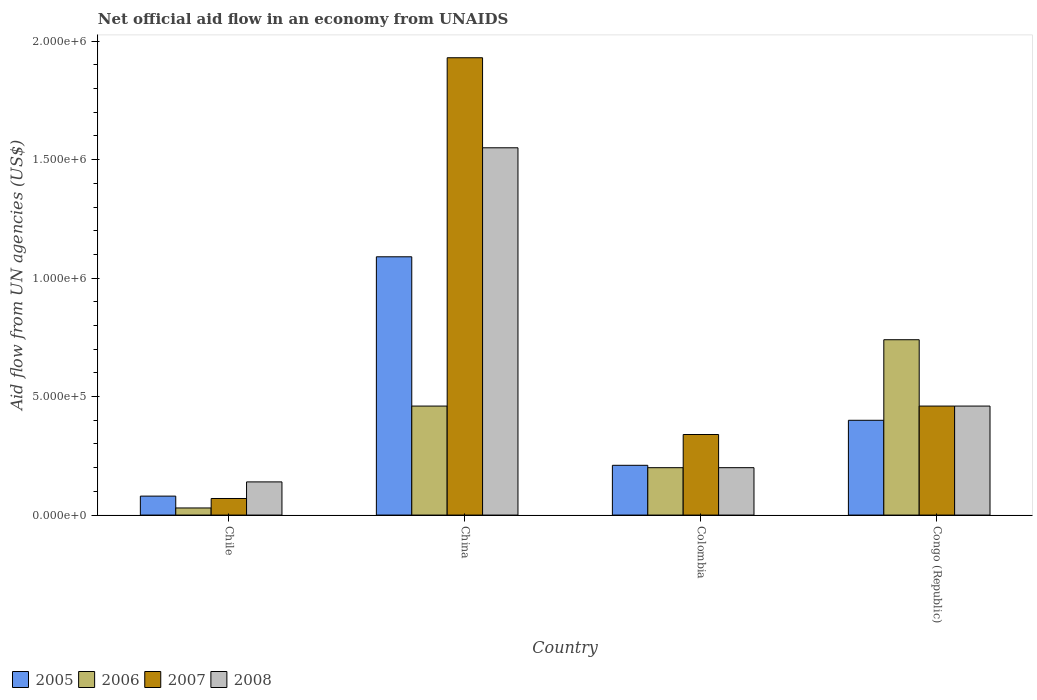How many different coloured bars are there?
Keep it short and to the point. 4. How many groups of bars are there?
Your answer should be compact. 4. Are the number of bars per tick equal to the number of legend labels?
Offer a terse response. Yes. How many bars are there on the 3rd tick from the right?
Ensure brevity in your answer.  4. What is the label of the 1st group of bars from the left?
Offer a terse response. Chile. Across all countries, what is the maximum net official aid flow in 2005?
Make the answer very short. 1.09e+06. Across all countries, what is the minimum net official aid flow in 2006?
Offer a very short reply. 3.00e+04. What is the total net official aid flow in 2008 in the graph?
Provide a short and direct response. 2.35e+06. What is the difference between the net official aid flow in 2006 in Colombia and that in Congo (Republic)?
Your response must be concise. -5.40e+05. What is the difference between the net official aid flow in 2005 in Chile and the net official aid flow in 2006 in China?
Provide a succinct answer. -3.80e+05. What is the difference between the net official aid flow of/in 2006 and net official aid flow of/in 2008 in China?
Ensure brevity in your answer.  -1.09e+06. In how many countries, is the net official aid flow in 2008 greater than 400000 US$?
Give a very brief answer. 2. Is the net official aid flow in 2007 in Chile less than that in Congo (Republic)?
Your answer should be compact. Yes. What is the difference between the highest and the second highest net official aid flow in 2006?
Your response must be concise. 2.80e+05. What is the difference between the highest and the lowest net official aid flow in 2008?
Ensure brevity in your answer.  1.41e+06. What does the 4th bar from the right in Colombia represents?
Your answer should be compact. 2005. Is it the case that in every country, the sum of the net official aid flow in 2006 and net official aid flow in 2005 is greater than the net official aid flow in 2008?
Provide a short and direct response. No. How many bars are there?
Give a very brief answer. 16. How many countries are there in the graph?
Ensure brevity in your answer.  4. Are the values on the major ticks of Y-axis written in scientific E-notation?
Make the answer very short. Yes. Does the graph contain grids?
Give a very brief answer. No. Where does the legend appear in the graph?
Your response must be concise. Bottom left. How are the legend labels stacked?
Keep it short and to the point. Horizontal. What is the title of the graph?
Offer a terse response. Net official aid flow in an economy from UNAIDS. What is the label or title of the X-axis?
Your answer should be compact. Country. What is the label or title of the Y-axis?
Keep it short and to the point. Aid flow from UN agencies (US$). What is the Aid flow from UN agencies (US$) in 2005 in China?
Provide a succinct answer. 1.09e+06. What is the Aid flow from UN agencies (US$) of 2006 in China?
Make the answer very short. 4.60e+05. What is the Aid flow from UN agencies (US$) in 2007 in China?
Your answer should be compact. 1.93e+06. What is the Aid flow from UN agencies (US$) of 2008 in China?
Make the answer very short. 1.55e+06. What is the Aid flow from UN agencies (US$) of 2005 in Colombia?
Offer a very short reply. 2.10e+05. What is the Aid flow from UN agencies (US$) in 2006 in Colombia?
Make the answer very short. 2.00e+05. What is the Aid flow from UN agencies (US$) of 2007 in Colombia?
Give a very brief answer. 3.40e+05. What is the Aid flow from UN agencies (US$) in 2005 in Congo (Republic)?
Your response must be concise. 4.00e+05. What is the Aid flow from UN agencies (US$) of 2006 in Congo (Republic)?
Provide a short and direct response. 7.40e+05. What is the Aid flow from UN agencies (US$) in 2007 in Congo (Republic)?
Offer a very short reply. 4.60e+05. Across all countries, what is the maximum Aid flow from UN agencies (US$) of 2005?
Your answer should be compact. 1.09e+06. Across all countries, what is the maximum Aid flow from UN agencies (US$) in 2006?
Your answer should be very brief. 7.40e+05. Across all countries, what is the maximum Aid flow from UN agencies (US$) of 2007?
Keep it short and to the point. 1.93e+06. Across all countries, what is the maximum Aid flow from UN agencies (US$) in 2008?
Ensure brevity in your answer.  1.55e+06. Across all countries, what is the minimum Aid flow from UN agencies (US$) in 2008?
Make the answer very short. 1.40e+05. What is the total Aid flow from UN agencies (US$) in 2005 in the graph?
Offer a very short reply. 1.78e+06. What is the total Aid flow from UN agencies (US$) in 2006 in the graph?
Provide a succinct answer. 1.43e+06. What is the total Aid flow from UN agencies (US$) in 2007 in the graph?
Provide a succinct answer. 2.80e+06. What is the total Aid flow from UN agencies (US$) of 2008 in the graph?
Provide a succinct answer. 2.35e+06. What is the difference between the Aid flow from UN agencies (US$) of 2005 in Chile and that in China?
Offer a very short reply. -1.01e+06. What is the difference between the Aid flow from UN agencies (US$) in 2006 in Chile and that in China?
Offer a very short reply. -4.30e+05. What is the difference between the Aid flow from UN agencies (US$) in 2007 in Chile and that in China?
Keep it short and to the point. -1.86e+06. What is the difference between the Aid flow from UN agencies (US$) of 2008 in Chile and that in China?
Provide a succinct answer. -1.41e+06. What is the difference between the Aid flow from UN agencies (US$) in 2006 in Chile and that in Colombia?
Keep it short and to the point. -1.70e+05. What is the difference between the Aid flow from UN agencies (US$) in 2007 in Chile and that in Colombia?
Give a very brief answer. -2.70e+05. What is the difference between the Aid flow from UN agencies (US$) in 2008 in Chile and that in Colombia?
Your answer should be very brief. -6.00e+04. What is the difference between the Aid flow from UN agencies (US$) of 2005 in Chile and that in Congo (Republic)?
Your response must be concise. -3.20e+05. What is the difference between the Aid flow from UN agencies (US$) in 2006 in Chile and that in Congo (Republic)?
Offer a terse response. -7.10e+05. What is the difference between the Aid flow from UN agencies (US$) of 2007 in Chile and that in Congo (Republic)?
Provide a succinct answer. -3.90e+05. What is the difference between the Aid flow from UN agencies (US$) in 2008 in Chile and that in Congo (Republic)?
Ensure brevity in your answer.  -3.20e+05. What is the difference between the Aid flow from UN agencies (US$) in 2005 in China and that in Colombia?
Your answer should be compact. 8.80e+05. What is the difference between the Aid flow from UN agencies (US$) in 2007 in China and that in Colombia?
Your answer should be very brief. 1.59e+06. What is the difference between the Aid flow from UN agencies (US$) of 2008 in China and that in Colombia?
Give a very brief answer. 1.35e+06. What is the difference between the Aid flow from UN agencies (US$) of 2005 in China and that in Congo (Republic)?
Your response must be concise. 6.90e+05. What is the difference between the Aid flow from UN agencies (US$) in 2006 in China and that in Congo (Republic)?
Offer a terse response. -2.80e+05. What is the difference between the Aid flow from UN agencies (US$) of 2007 in China and that in Congo (Republic)?
Make the answer very short. 1.47e+06. What is the difference between the Aid flow from UN agencies (US$) in 2008 in China and that in Congo (Republic)?
Make the answer very short. 1.09e+06. What is the difference between the Aid flow from UN agencies (US$) of 2006 in Colombia and that in Congo (Republic)?
Your response must be concise. -5.40e+05. What is the difference between the Aid flow from UN agencies (US$) in 2007 in Colombia and that in Congo (Republic)?
Your response must be concise. -1.20e+05. What is the difference between the Aid flow from UN agencies (US$) in 2005 in Chile and the Aid flow from UN agencies (US$) in 2006 in China?
Your answer should be very brief. -3.80e+05. What is the difference between the Aid flow from UN agencies (US$) of 2005 in Chile and the Aid flow from UN agencies (US$) of 2007 in China?
Provide a short and direct response. -1.85e+06. What is the difference between the Aid flow from UN agencies (US$) in 2005 in Chile and the Aid flow from UN agencies (US$) in 2008 in China?
Provide a short and direct response. -1.47e+06. What is the difference between the Aid flow from UN agencies (US$) of 2006 in Chile and the Aid flow from UN agencies (US$) of 2007 in China?
Your answer should be very brief. -1.90e+06. What is the difference between the Aid flow from UN agencies (US$) in 2006 in Chile and the Aid flow from UN agencies (US$) in 2008 in China?
Your response must be concise. -1.52e+06. What is the difference between the Aid flow from UN agencies (US$) in 2007 in Chile and the Aid flow from UN agencies (US$) in 2008 in China?
Your answer should be very brief. -1.48e+06. What is the difference between the Aid flow from UN agencies (US$) of 2005 in Chile and the Aid flow from UN agencies (US$) of 2006 in Colombia?
Provide a short and direct response. -1.20e+05. What is the difference between the Aid flow from UN agencies (US$) of 2005 in Chile and the Aid flow from UN agencies (US$) of 2007 in Colombia?
Provide a short and direct response. -2.60e+05. What is the difference between the Aid flow from UN agencies (US$) of 2006 in Chile and the Aid flow from UN agencies (US$) of 2007 in Colombia?
Keep it short and to the point. -3.10e+05. What is the difference between the Aid flow from UN agencies (US$) of 2007 in Chile and the Aid flow from UN agencies (US$) of 2008 in Colombia?
Your answer should be compact. -1.30e+05. What is the difference between the Aid flow from UN agencies (US$) of 2005 in Chile and the Aid flow from UN agencies (US$) of 2006 in Congo (Republic)?
Ensure brevity in your answer.  -6.60e+05. What is the difference between the Aid flow from UN agencies (US$) of 2005 in Chile and the Aid flow from UN agencies (US$) of 2007 in Congo (Republic)?
Give a very brief answer. -3.80e+05. What is the difference between the Aid flow from UN agencies (US$) in 2005 in Chile and the Aid flow from UN agencies (US$) in 2008 in Congo (Republic)?
Your response must be concise. -3.80e+05. What is the difference between the Aid flow from UN agencies (US$) in 2006 in Chile and the Aid flow from UN agencies (US$) in 2007 in Congo (Republic)?
Ensure brevity in your answer.  -4.30e+05. What is the difference between the Aid flow from UN agencies (US$) of 2006 in Chile and the Aid flow from UN agencies (US$) of 2008 in Congo (Republic)?
Make the answer very short. -4.30e+05. What is the difference between the Aid flow from UN agencies (US$) in 2007 in Chile and the Aid flow from UN agencies (US$) in 2008 in Congo (Republic)?
Provide a short and direct response. -3.90e+05. What is the difference between the Aid flow from UN agencies (US$) of 2005 in China and the Aid flow from UN agencies (US$) of 2006 in Colombia?
Offer a terse response. 8.90e+05. What is the difference between the Aid flow from UN agencies (US$) in 2005 in China and the Aid flow from UN agencies (US$) in 2007 in Colombia?
Your answer should be very brief. 7.50e+05. What is the difference between the Aid flow from UN agencies (US$) in 2005 in China and the Aid flow from UN agencies (US$) in 2008 in Colombia?
Ensure brevity in your answer.  8.90e+05. What is the difference between the Aid flow from UN agencies (US$) of 2007 in China and the Aid flow from UN agencies (US$) of 2008 in Colombia?
Make the answer very short. 1.73e+06. What is the difference between the Aid flow from UN agencies (US$) in 2005 in China and the Aid flow from UN agencies (US$) in 2007 in Congo (Republic)?
Offer a terse response. 6.30e+05. What is the difference between the Aid flow from UN agencies (US$) in 2005 in China and the Aid flow from UN agencies (US$) in 2008 in Congo (Republic)?
Make the answer very short. 6.30e+05. What is the difference between the Aid flow from UN agencies (US$) of 2006 in China and the Aid flow from UN agencies (US$) of 2008 in Congo (Republic)?
Ensure brevity in your answer.  0. What is the difference between the Aid flow from UN agencies (US$) of 2007 in China and the Aid flow from UN agencies (US$) of 2008 in Congo (Republic)?
Make the answer very short. 1.47e+06. What is the difference between the Aid flow from UN agencies (US$) in 2005 in Colombia and the Aid flow from UN agencies (US$) in 2006 in Congo (Republic)?
Keep it short and to the point. -5.30e+05. What is the difference between the Aid flow from UN agencies (US$) of 2005 in Colombia and the Aid flow from UN agencies (US$) of 2007 in Congo (Republic)?
Provide a short and direct response. -2.50e+05. What is the difference between the Aid flow from UN agencies (US$) in 2005 in Colombia and the Aid flow from UN agencies (US$) in 2008 in Congo (Republic)?
Provide a short and direct response. -2.50e+05. What is the difference between the Aid flow from UN agencies (US$) of 2006 in Colombia and the Aid flow from UN agencies (US$) of 2007 in Congo (Republic)?
Keep it short and to the point. -2.60e+05. What is the difference between the Aid flow from UN agencies (US$) of 2006 in Colombia and the Aid flow from UN agencies (US$) of 2008 in Congo (Republic)?
Ensure brevity in your answer.  -2.60e+05. What is the average Aid flow from UN agencies (US$) in 2005 per country?
Your answer should be compact. 4.45e+05. What is the average Aid flow from UN agencies (US$) in 2006 per country?
Your answer should be very brief. 3.58e+05. What is the average Aid flow from UN agencies (US$) in 2008 per country?
Provide a succinct answer. 5.88e+05. What is the difference between the Aid flow from UN agencies (US$) in 2005 and Aid flow from UN agencies (US$) in 2006 in Chile?
Your answer should be very brief. 5.00e+04. What is the difference between the Aid flow from UN agencies (US$) in 2005 and Aid flow from UN agencies (US$) in 2007 in Chile?
Make the answer very short. 10000. What is the difference between the Aid flow from UN agencies (US$) of 2005 and Aid flow from UN agencies (US$) of 2008 in Chile?
Keep it short and to the point. -6.00e+04. What is the difference between the Aid flow from UN agencies (US$) in 2006 and Aid flow from UN agencies (US$) in 2007 in Chile?
Keep it short and to the point. -4.00e+04. What is the difference between the Aid flow from UN agencies (US$) of 2005 and Aid flow from UN agencies (US$) of 2006 in China?
Your answer should be very brief. 6.30e+05. What is the difference between the Aid flow from UN agencies (US$) in 2005 and Aid flow from UN agencies (US$) in 2007 in China?
Provide a succinct answer. -8.40e+05. What is the difference between the Aid flow from UN agencies (US$) in 2005 and Aid flow from UN agencies (US$) in 2008 in China?
Give a very brief answer. -4.60e+05. What is the difference between the Aid flow from UN agencies (US$) in 2006 and Aid flow from UN agencies (US$) in 2007 in China?
Provide a short and direct response. -1.47e+06. What is the difference between the Aid flow from UN agencies (US$) in 2006 and Aid flow from UN agencies (US$) in 2008 in China?
Keep it short and to the point. -1.09e+06. What is the difference between the Aid flow from UN agencies (US$) of 2005 and Aid flow from UN agencies (US$) of 2007 in Colombia?
Provide a succinct answer. -1.30e+05. What is the difference between the Aid flow from UN agencies (US$) in 2006 and Aid flow from UN agencies (US$) in 2008 in Colombia?
Give a very brief answer. 0. What is the difference between the Aid flow from UN agencies (US$) in 2005 and Aid flow from UN agencies (US$) in 2006 in Congo (Republic)?
Provide a succinct answer. -3.40e+05. What is the difference between the Aid flow from UN agencies (US$) in 2005 and Aid flow from UN agencies (US$) in 2007 in Congo (Republic)?
Your response must be concise. -6.00e+04. What is the difference between the Aid flow from UN agencies (US$) in 2005 and Aid flow from UN agencies (US$) in 2008 in Congo (Republic)?
Your answer should be very brief. -6.00e+04. What is the difference between the Aid flow from UN agencies (US$) in 2006 and Aid flow from UN agencies (US$) in 2007 in Congo (Republic)?
Ensure brevity in your answer.  2.80e+05. What is the difference between the Aid flow from UN agencies (US$) in 2006 and Aid flow from UN agencies (US$) in 2008 in Congo (Republic)?
Keep it short and to the point. 2.80e+05. What is the ratio of the Aid flow from UN agencies (US$) in 2005 in Chile to that in China?
Offer a terse response. 0.07. What is the ratio of the Aid flow from UN agencies (US$) of 2006 in Chile to that in China?
Provide a succinct answer. 0.07. What is the ratio of the Aid flow from UN agencies (US$) in 2007 in Chile to that in China?
Provide a succinct answer. 0.04. What is the ratio of the Aid flow from UN agencies (US$) of 2008 in Chile to that in China?
Provide a succinct answer. 0.09. What is the ratio of the Aid flow from UN agencies (US$) in 2005 in Chile to that in Colombia?
Your response must be concise. 0.38. What is the ratio of the Aid flow from UN agencies (US$) in 2006 in Chile to that in Colombia?
Keep it short and to the point. 0.15. What is the ratio of the Aid flow from UN agencies (US$) of 2007 in Chile to that in Colombia?
Your response must be concise. 0.21. What is the ratio of the Aid flow from UN agencies (US$) of 2005 in Chile to that in Congo (Republic)?
Provide a succinct answer. 0.2. What is the ratio of the Aid flow from UN agencies (US$) of 2006 in Chile to that in Congo (Republic)?
Provide a short and direct response. 0.04. What is the ratio of the Aid flow from UN agencies (US$) in 2007 in Chile to that in Congo (Republic)?
Make the answer very short. 0.15. What is the ratio of the Aid flow from UN agencies (US$) of 2008 in Chile to that in Congo (Republic)?
Keep it short and to the point. 0.3. What is the ratio of the Aid flow from UN agencies (US$) of 2005 in China to that in Colombia?
Offer a very short reply. 5.19. What is the ratio of the Aid flow from UN agencies (US$) in 2007 in China to that in Colombia?
Make the answer very short. 5.68. What is the ratio of the Aid flow from UN agencies (US$) of 2008 in China to that in Colombia?
Ensure brevity in your answer.  7.75. What is the ratio of the Aid flow from UN agencies (US$) in 2005 in China to that in Congo (Republic)?
Ensure brevity in your answer.  2.73. What is the ratio of the Aid flow from UN agencies (US$) of 2006 in China to that in Congo (Republic)?
Make the answer very short. 0.62. What is the ratio of the Aid flow from UN agencies (US$) in 2007 in China to that in Congo (Republic)?
Keep it short and to the point. 4.2. What is the ratio of the Aid flow from UN agencies (US$) in 2008 in China to that in Congo (Republic)?
Your answer should be compact. 3.37. What is the ratio of the Aid flow from UN agencies (US$) in 2005 in Colombia to that in Congo (Republic)?
Ensure brevity in your answer.  0.53. What is the ratio of the Aid flow from UN agencies (US$) in 2006 in Colombia to that in Congo (Republic)?
Offer a very short reply. 0.27. What is the ratio of the Aid flow from UN agencies (US$) in 2007 in Colombia to that in Congo (Republic)?
Give a very brief answer. 0.74. What is the ratio of the Aid flow from UN agencies (US$) of 2008 in Colombia to that in Congo (Republic)?
Offer a very short reply. 0.43. What is the difference between the highest and the second highest Aid flow from UN agencies (US$) of 2005?
Provide a short and direct response. 6.90e+05. What is the difference between the highest and the second highest Aid flow from UN agencies (US$) of 2006?
Provide a short and direct response. 2.80e+05. What is the difference between the highest and the second highest Aid flow from UN agencies (US$) in 2007?
Give a very brief answer. 1.47e+06. What is the difference between the highest and the second highest Aid flow from UN agencies (US$) of 2008?
Give a very brief answer. 1.09e+06. What is the difference between the highest and the lowest Aid flow from UN agencies (US$) in 2005?
Your answer should be compact. 1.01e+06. What is the difference between the highest and the lowest Aid flow from UN agencies (US$) of 2006?
Make the answer very short. 7.10e+05. What is the difference between the highest and the lowest Aid flow from UN agencies (US$) in 2007?
Offer a terse response. 1.86e+06. What is the difference between the highest and the lowest Aid flow from UN agencies (US$) in 2008?
Provide a short and direct response. 1.41e+06. 